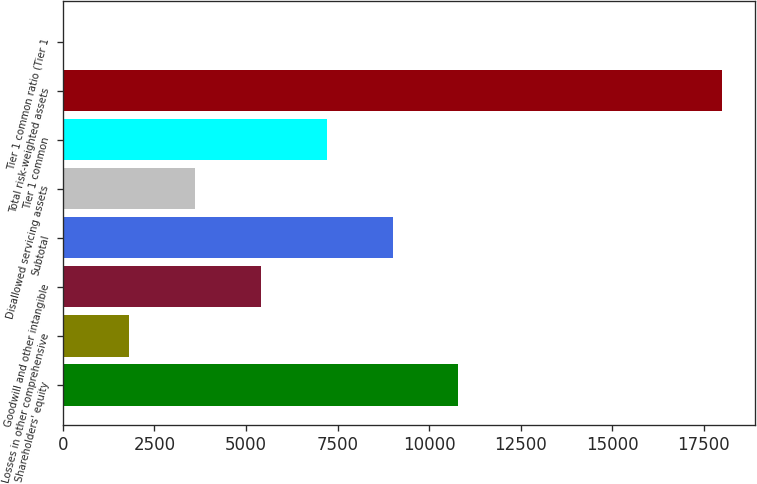Convert chart. <chart><loc_0><loc_0><loc_500><loc_500><bar_chart><fcel>Shareholders' equity<fcel>Losses in other comprehensive<fcel>Goodwill and other intangible<fcel>Subtotal<fcel>Disallowed servicing assets<fcel>Tier 1 common<fcel>Total risk-weighted assets<fcel>Tier 1 common ratio (Tier 1<nl><fcel>10800.7<fcel>1811.61<fcel>5407.23<fcel>9002.85<fcel>3609.42<fcel>7205.04<fcel>17991.9<fcel>13.8<nl></chart> 